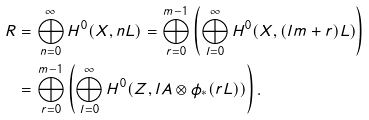<formula> <loc_0><loc_0><loc_500><loc_500>R & = \bigoplus _ { n = 0 } ^ { \infty } H ^ { 0 } ( X , n L ) = \bigoplus _ { r = 0 } ^ { m - 1 } \left ( \bigoplus _ { l = 0 } ^ { \infty } H ^ { 0 } ( X , ( l m + r ) L ) \right ) \\ & = \bigoplus _ { r = 0 } ^ { m - 1 } \left ( \bigoplus _ { l = 0 } ^ { \infty } H ^ { 0 } ( Z , l A \otimes \phi _ { * } ( r L ) ) \right ) .</formula> 